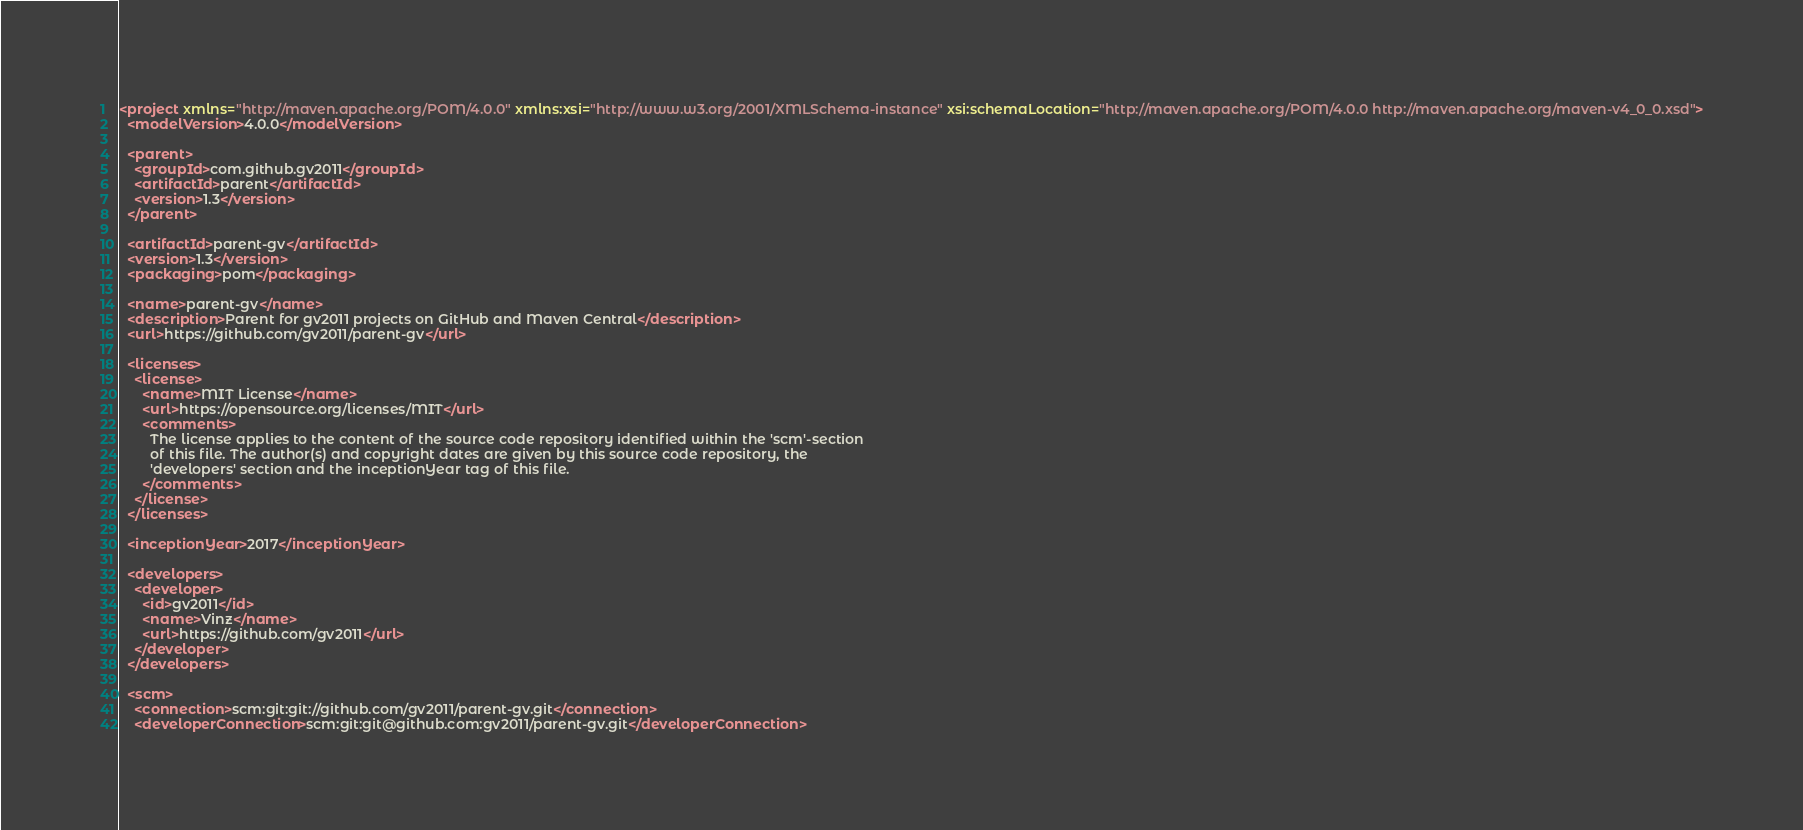<code> <loc_0><loc_0><loc_500><loc_500><_XML_><project xmlns="http://maven.apache.org/POM/4.0.0" xmlns:xsi="http://www.w3.org/2001/XMLSchema-instance" xsi:schemaLocation="http://maven.apache.org/POM/4.0.0 http://maven.apache.org/maven-v4_0_0.xsd">
  <modelVersion>4.0.0</modelVersion>

  <parent>
    <groupId>com.github.gv2011</groupId>
    <artifactId>parent</artifactId>
    <version>1.3</version>
  </parent>

  <artifactId>parent-gv</artifactId>
  <version>1.3</version>
  <packaging>pom</packaging>

  <name>parent-gv</name>
  <description>Parent for gv2011 projects on GitHub and Maven Central</description>
  <url>https://github.com/gv2011/parent-gv</url>

  <licenses>
    <license>
      <name>MIT License</name>
      <url>https://opensource.org/licenses/MIT</url>
      <comments>
        The license applies to the content of the source code repository identified within the 'scm'-section
        of this file. The author(s) and copyright dates are given by this source code repository, the
        'developers' section and the inceptionYear tag of this file.
      </comments>
    </license>
  </licenses>
  
  <inceptionYear>2017</inceptionYear>

  <developers>
    <developer>
      <id>gv2011</id>
      <name>Vinz</name>
      <url>https://github.com/gv2011</url>
    </developer>
  </developers>
  
  <scm>
    <connection>scm:git:git://github.com/gv2011/parent-gv.git</connection>
    <developerConnection>scm:git:git@github.com:gv2011/parent-gv.git</developerConnection></code> 